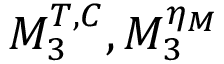Convert formula to latex. <formula><loc_0><loc_0><loc_500><loc_500>M _ { 3 } ^ { T , C } , M _ { 3 } ^ { \eta _ { M } }</formula> 